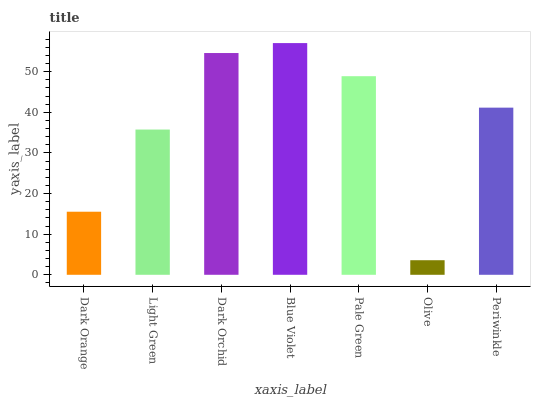Is Olive the minimum?
Answer yes or no. Yes. Is Blue Violet the maximum?
Answer yes or no. Yes. Is Light Green the minimum?
Answer yes or no. No. Is Light Green the maximum?
Answer yes or no. No. Is Light Green greater than Dark Orange?
Answer yes or no. Yes. Is Dark Orange less than Light Green?
Answer yes or no. Yes. Is Dark Orange greater than Light Green?
Answer yes or no. No. Is Light Green less than Dark Orange?
Answer yes or no. No. Is Periwinkle the high median?
Answer yes or no. Yes. Is Periwinkle the low median?
Answer yes or no. Yes. Is Dark Orchid the high median?
Answer yes or no. No. Is Dark Orchid the low median?
Answer yes or no. No. 